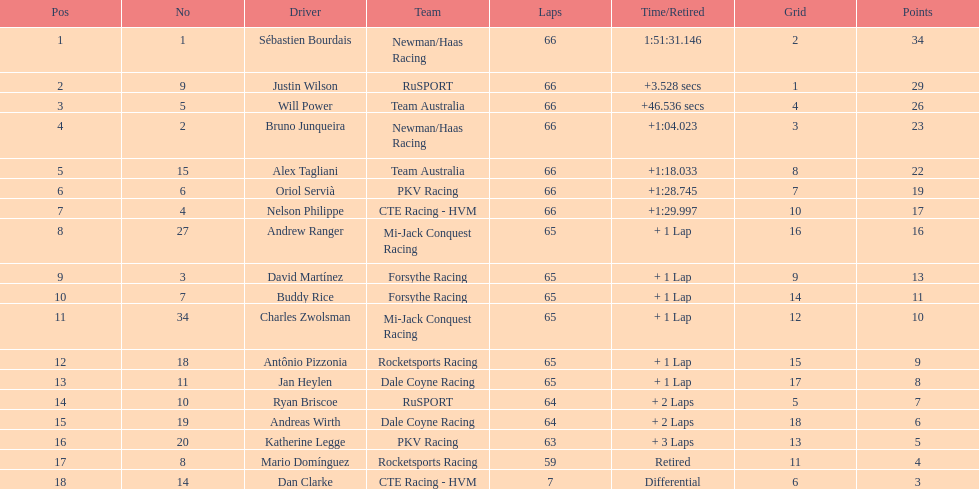Who was the final finisher at the 2006 gran premio telmex? Dan Clarke. 